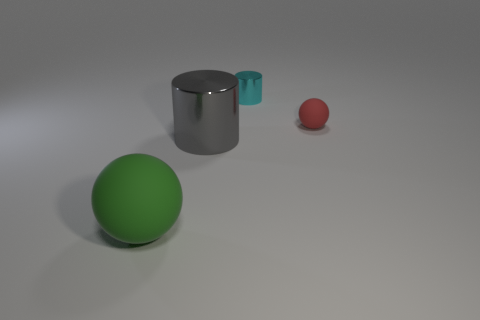Add 2 cubes. How many objects exist? 6 Add 2 big things. How many big things are left? 4 Add 3 big gray things. How many big gray things exist? 4 Subtract 0 yellow cubes. How many objects are left? 4 Subtract 2 spheres. How many spheres are left? 0 Subtract all purple spheres. Subtract all red blocks. How many spheres are left? 2 Subtract all green spheres. How many cyan cylinders are left? 1 Subtract all large green objects. Subtract all tiny rubber spheres. How many objects are left? 2 